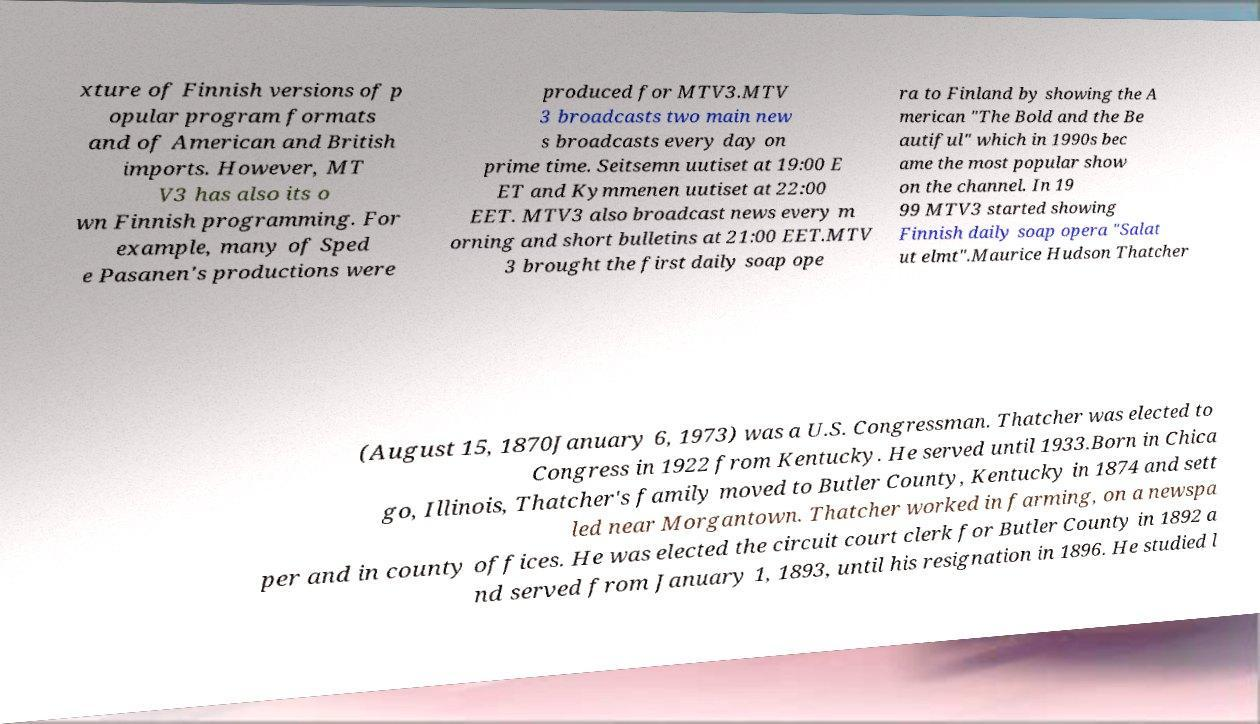Could you assist in decoding the text presented in this image and type it out clearly? xture of Finnish versions of p opular program formats and of American and British imports. However, MT V3 has also its o wn Finnish programming. For example, many of Sped e Pasanen's productions were produced for MTV3.MTV 3 broadcasts two main new s broadcasts every day on prime time. Seitsemn uutiset at 19:00 E ET and Kymmenen uutiset at 22:00 EET. MTV3 also broadcast news every m orning and short bulletins at 21:00 EET.MTV 3 brought the first daily soap ope ra to Finland by showing the A merican "The Bold and the Be autiful" which in 1990s bec ame the most popular show on the channel. In 19 99 MTV3 started showing Finnish daily soap opera "Salat ut elmt".Maurice Hudson Thatcher (August 15, 1870January 6, 1973) was a U.S. Congressman. Thatcher was elected to Congress in 1922 from Kentucky. He served until 1933.Born in Chica go, Illinois, Thatcher's family moved to Butler County, Kentucky in 1874 and sett led near Morgantown. Thatcher worked in farming, on a newspa per and in county offices. He was elected the circuit court clerk for Butler County in 1892 a nd served from January 1, 1893, until his resignation in 1896. He studied l 